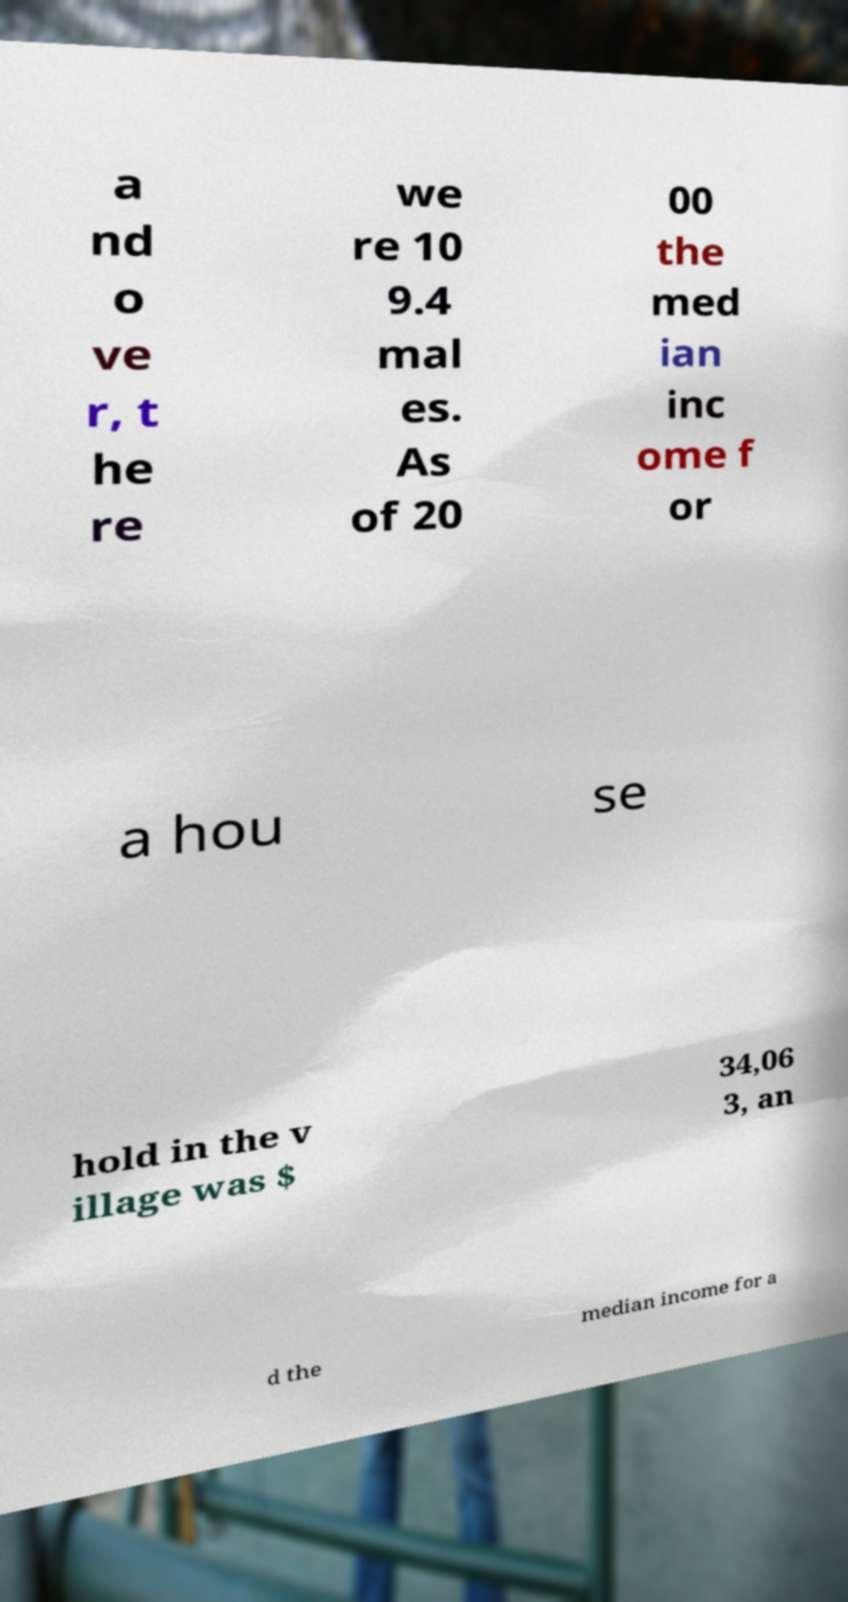Can you read and provide the text displayed in the image?This photo seems to have some interesting text. Can you extract and type it out for me? a nd o ve r, t he re we re 10 9.4 mal es. As of 20 00 the med ian inc ome f or a hou se hold in the v illage was $ 34,06 3, an d the median income for a 